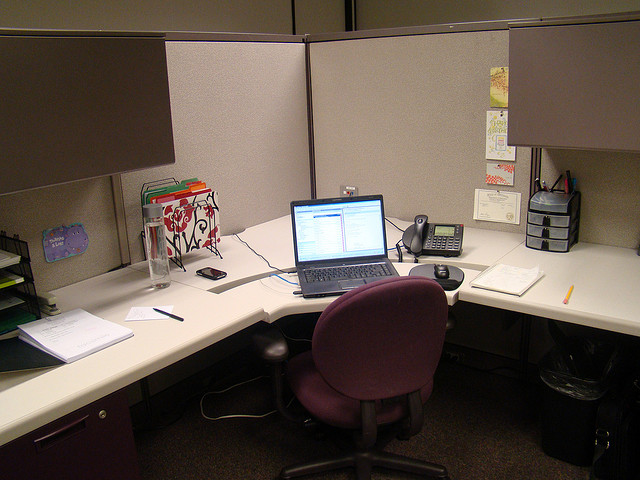<image>Whose office is this? It is unknown whose office this is. The office could belong to a worker, a boss, or someone in human resources. Whose office is this? I don't know whose office this is. It can be someone's office, a worker's office, or an employee's office. 